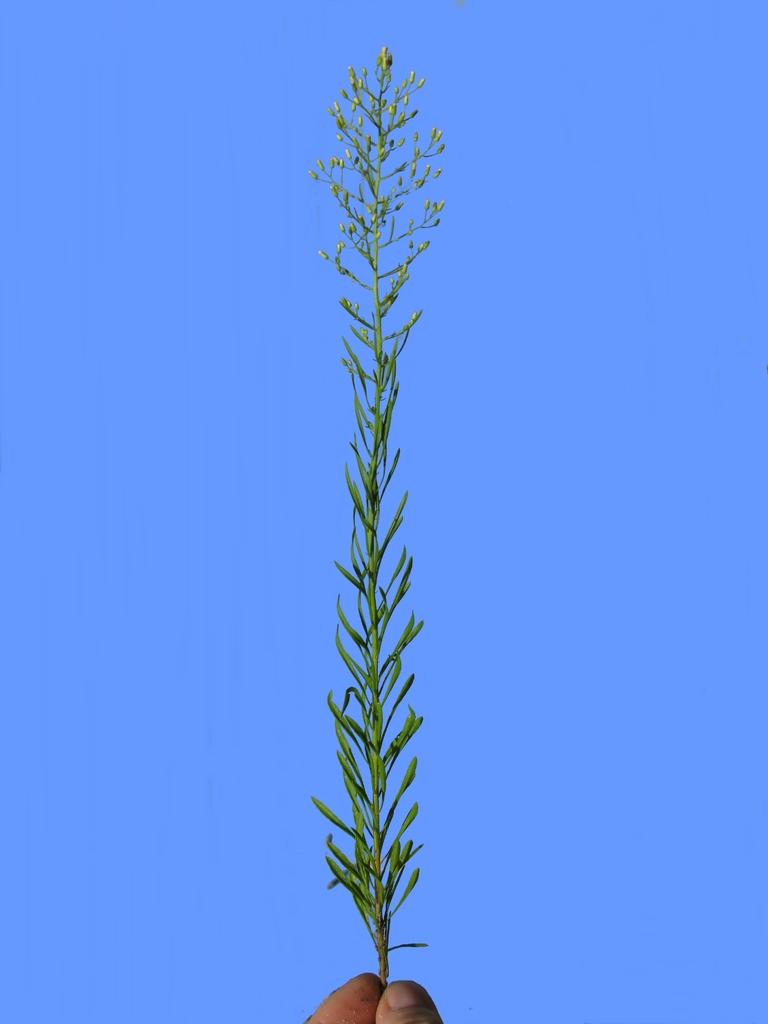What is the person's hand holding in the image? The person's hand is holding grass in the image. What can be seen in the background of the image? There is sky visible in the background of the image. What type of fiction is the person reading in the image? There is no book or any form of fiction present in the image; it only shows a person's hand holding grass with sky visible in the background. 